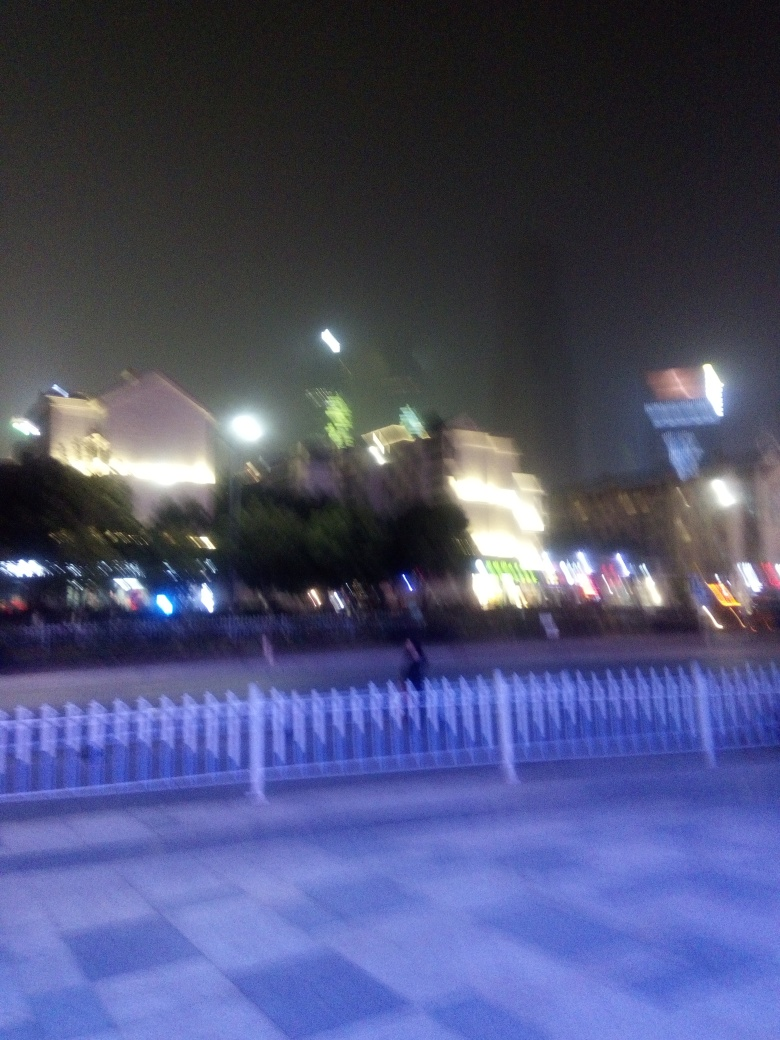Can you guess why the image might be blurry? The blurriness could be due to a few factors: the camera might have been in motion during the shot, the photograph could have been taken with a slow shutter speed in a low-light condition, or it may have been a deliberate artistic choice to convey a sense of movement or activity. Do you think the blur affects the mood of the picture? Absolutely, the blur contributes to a sense of dynamism and ephemeral quality, almost as if capturing a fleeting moment in a bustling night scene. It can also evoke a sense of mystery or disorientation, adding to the atmospheric quality of the photo. 